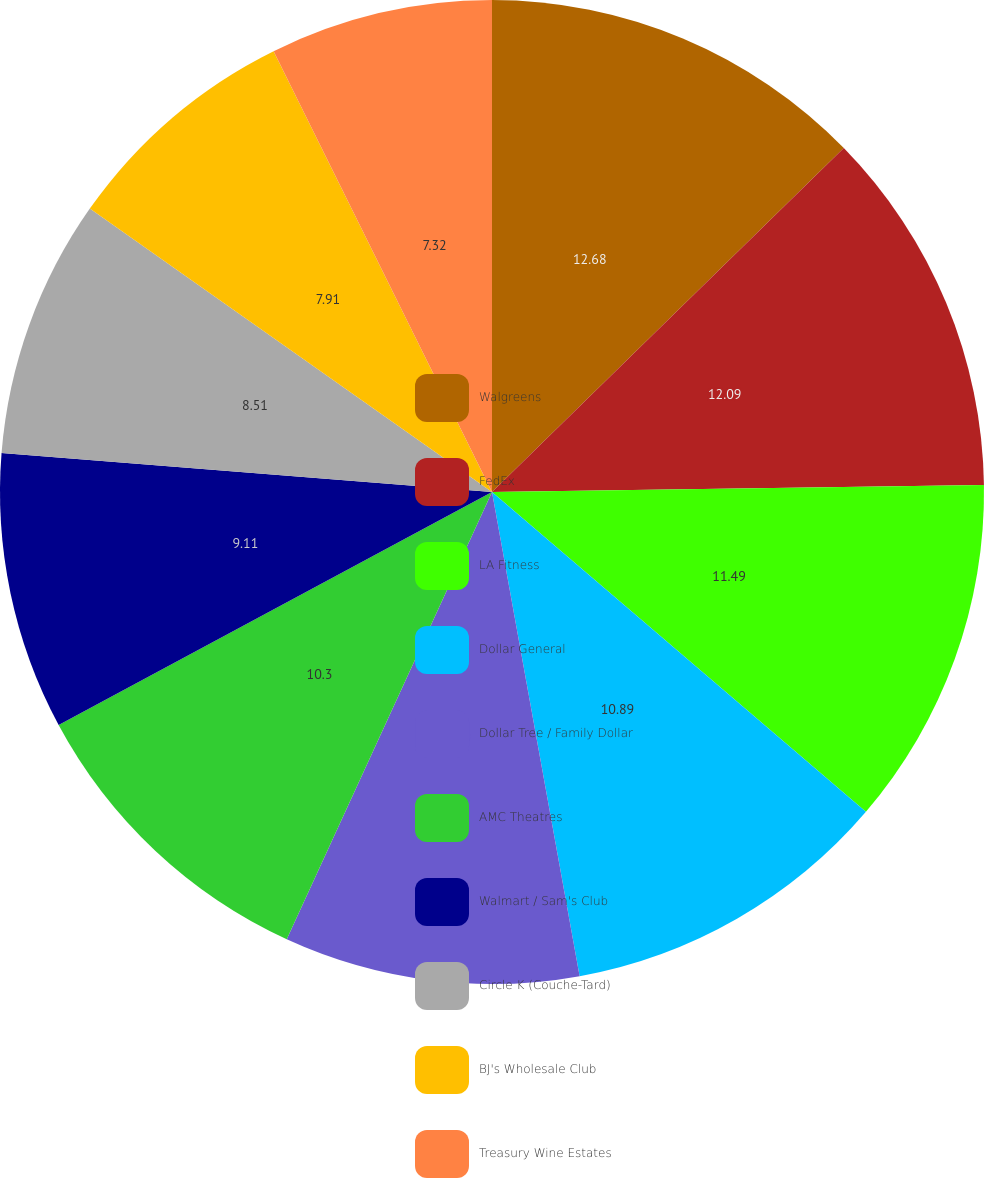Convert chart to OTSL. <chart><loc_0><loc_0><loc_500><loc_500><pie_chart><fcel>Walgreens<fcel>FedEx<fcel>LA Fitness<fcel>Dollar General<fcel>Dollar Tree / Family Dollar<fcel>AMC Theatres<fcel>Walmart / Sam's Club<fcel>Circle K (Couche-Tard)<fcel>BJ's Wholesale Club<fcel>Treasury Wine Estates<nl><fcel>12.68%<fcel>12.09%<fcel>11.49%<fcel>10.89%<fcel>9.7%<fcel>10.3%<fcel>9.11%<fcel>8.51%<fcel>7.91%<fcel>7.32%<nl></chart> 